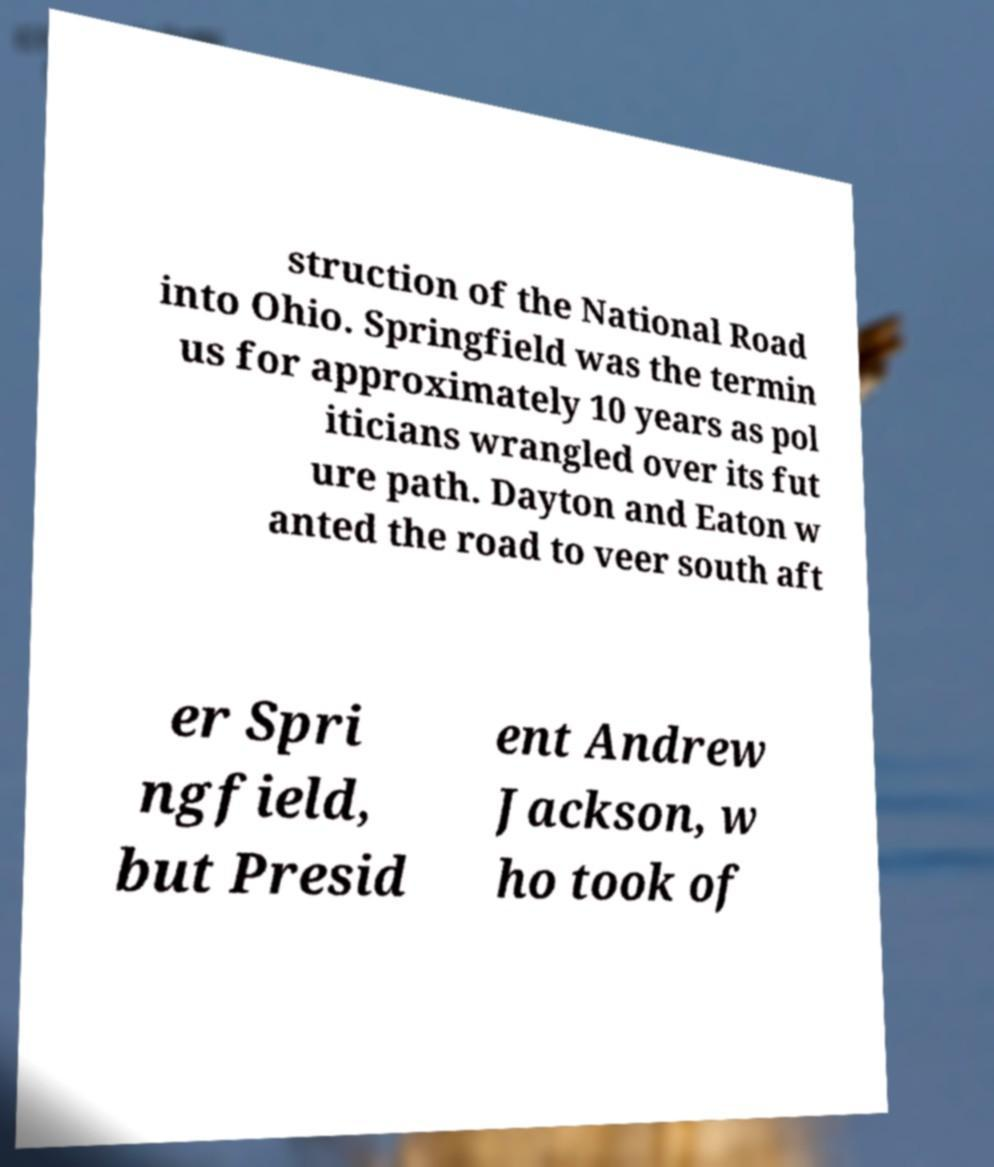Please read and relay the text visible in this image. What does it say? struction of the National Road into Ohio. Springfield was the termin us for approximately 10 years as pol iticians wrangled over its fut ure path. Dayton and Eaton w anted the road to veer south aft er Spri ngfield, but Presid ent Andrew Jackson, w ho took of 